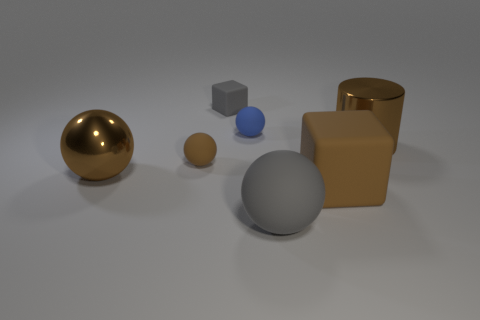What is the brown sphere on the right side of the large metal object that is on the left side of the tiny brown matte thing made of?
Your answer should be very brief. Rubber. There is a cube that is behind the big matte cube; what size is it?
Provide a succinct answer. Small. What is the color of the ball that is on the left side of the small blue matte thing and to the right of the large metallic sphere?
Provide a succinct answer. Brown. There is a gray thing left of the gray sphere; does it have the same size as the tiny blue ball?
Provide a short and direct response. Yes. Are there any big cylinders behind the big brown metallic thing that is on the left side of the cylinder?
Provide a succinct answer. Yes. What material is the brown block?
Provide a short and direct response. Rubber. There is a small gray object; are there any large metal objects to the left of it?
Offer a terse response. Yes. There is a gray matte thing that is the same shape as the tiny brown matte object; what size is it?
Your response must be concise. Large. Is the number of rubber balls behind the big brown rubber cube the same as the number of large brown metallic things in front of the tiny gray cube?
Offer a very short reply. Yes. What number of cubes are there?
Give a very brief answer. 2. 